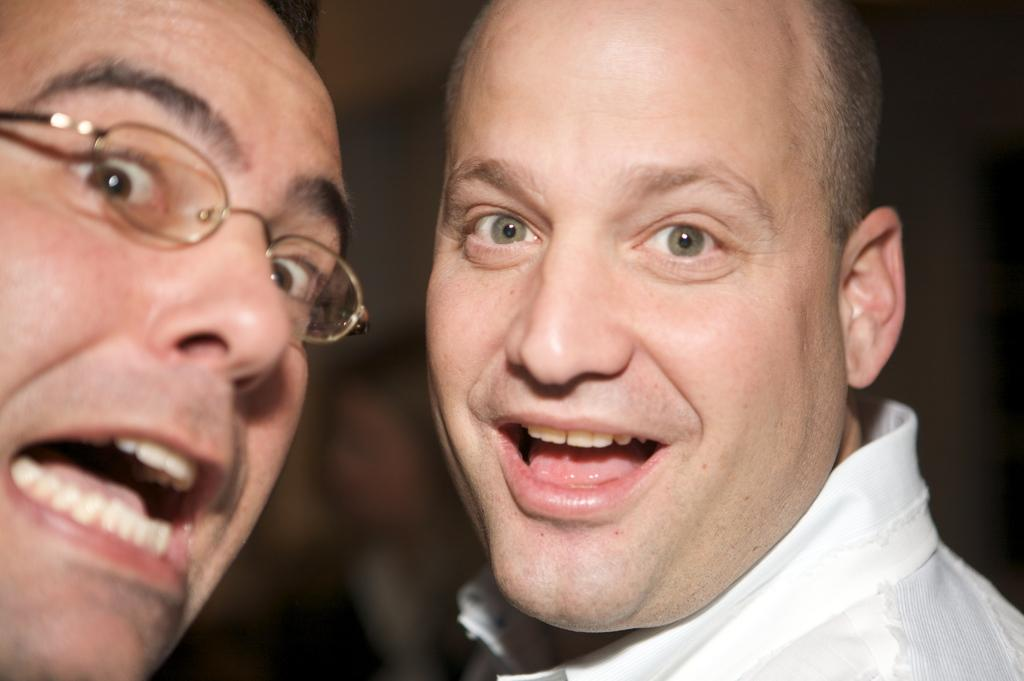How many people are in the image? There are two men in the image. Can you describe one of the men in the image? One of the men is wearing spectacles. What type of match is the man holding in the image? There is no match or any object being held by the men in the image. 